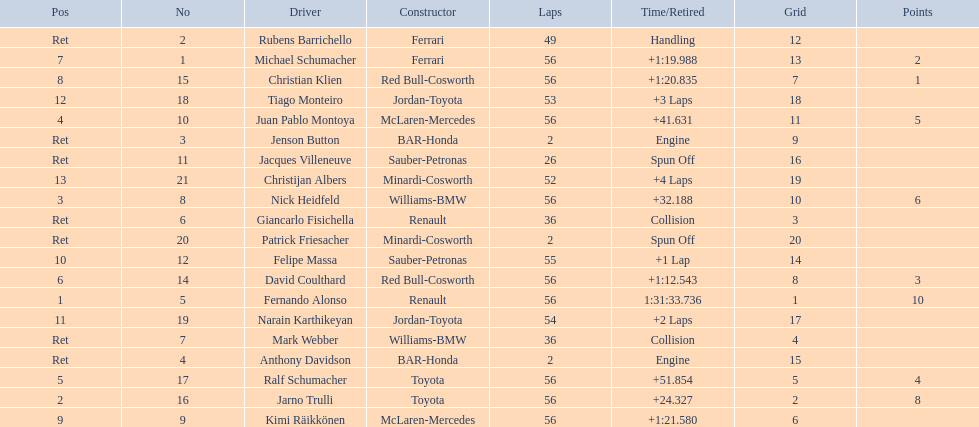How many laps did the first-place winner complete in total? 56. 